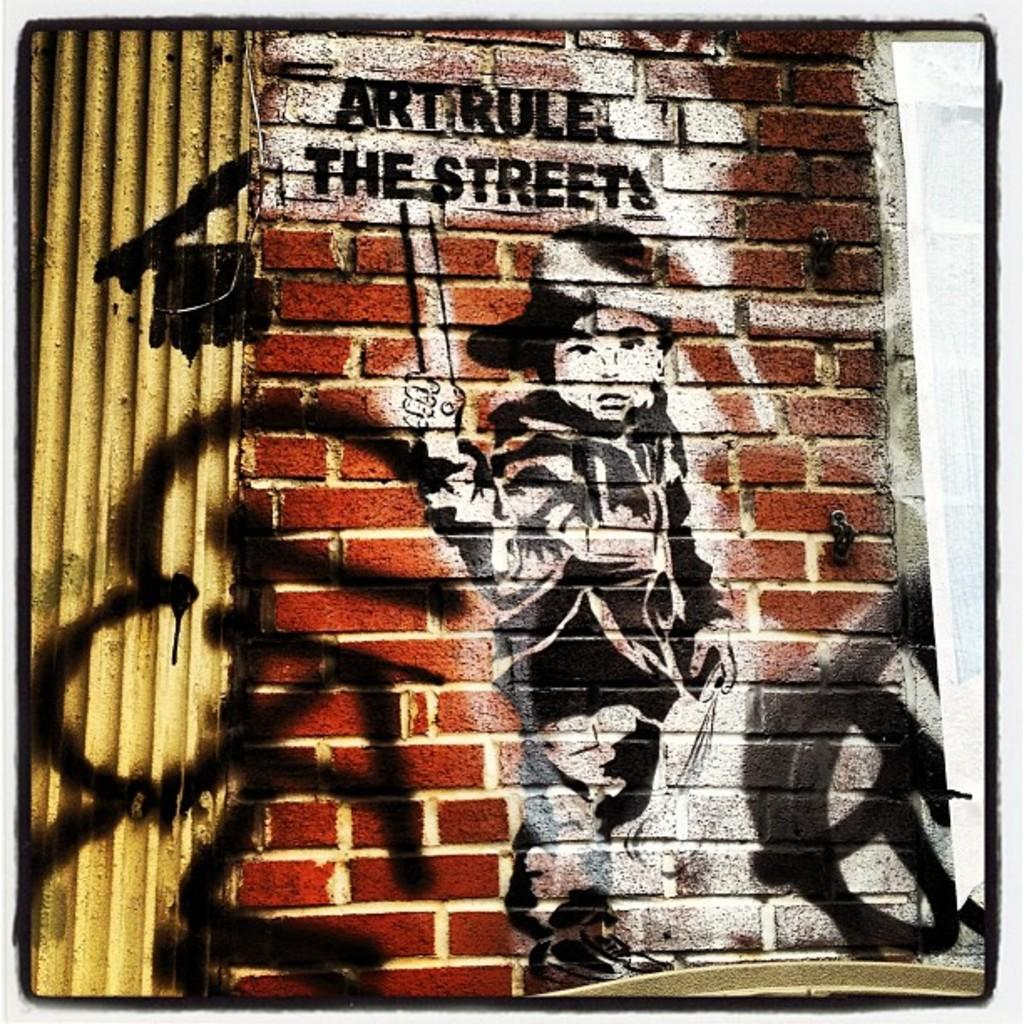What can be seen on the wall in the image? There is a depiction of a person on the wall in the image. Is there any text on the wall? Yes, there is text on the wall. What is located on the left side of the image? There is a metal frame on the left side of the image. How many monkeys are climbing on the wall in the image? There are no monkeys present in the image; it features a depiction of a person on the wall. What type of observation can be made about the babies in the image? There are no babies present in the image. 